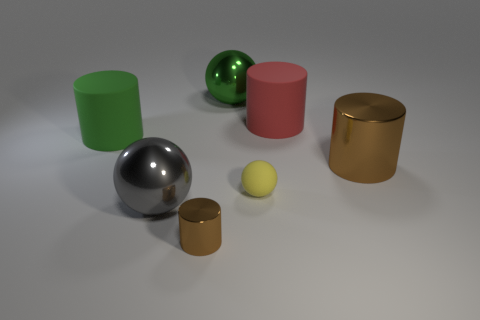Add 3 big cylinders. How many objects exist? 10 Subtract all cylinders. How many objects are left? 3 Add 1 metallic cylinders. How many metallic cylinders exist? 3 Subtract 0 gray cylinders. How many objects are left? 7 Subtract all cylinders. Subtract all small cyan matte cylinders. How many objects are left? 3 Add 2 green objects. How many green objects are left? 4 